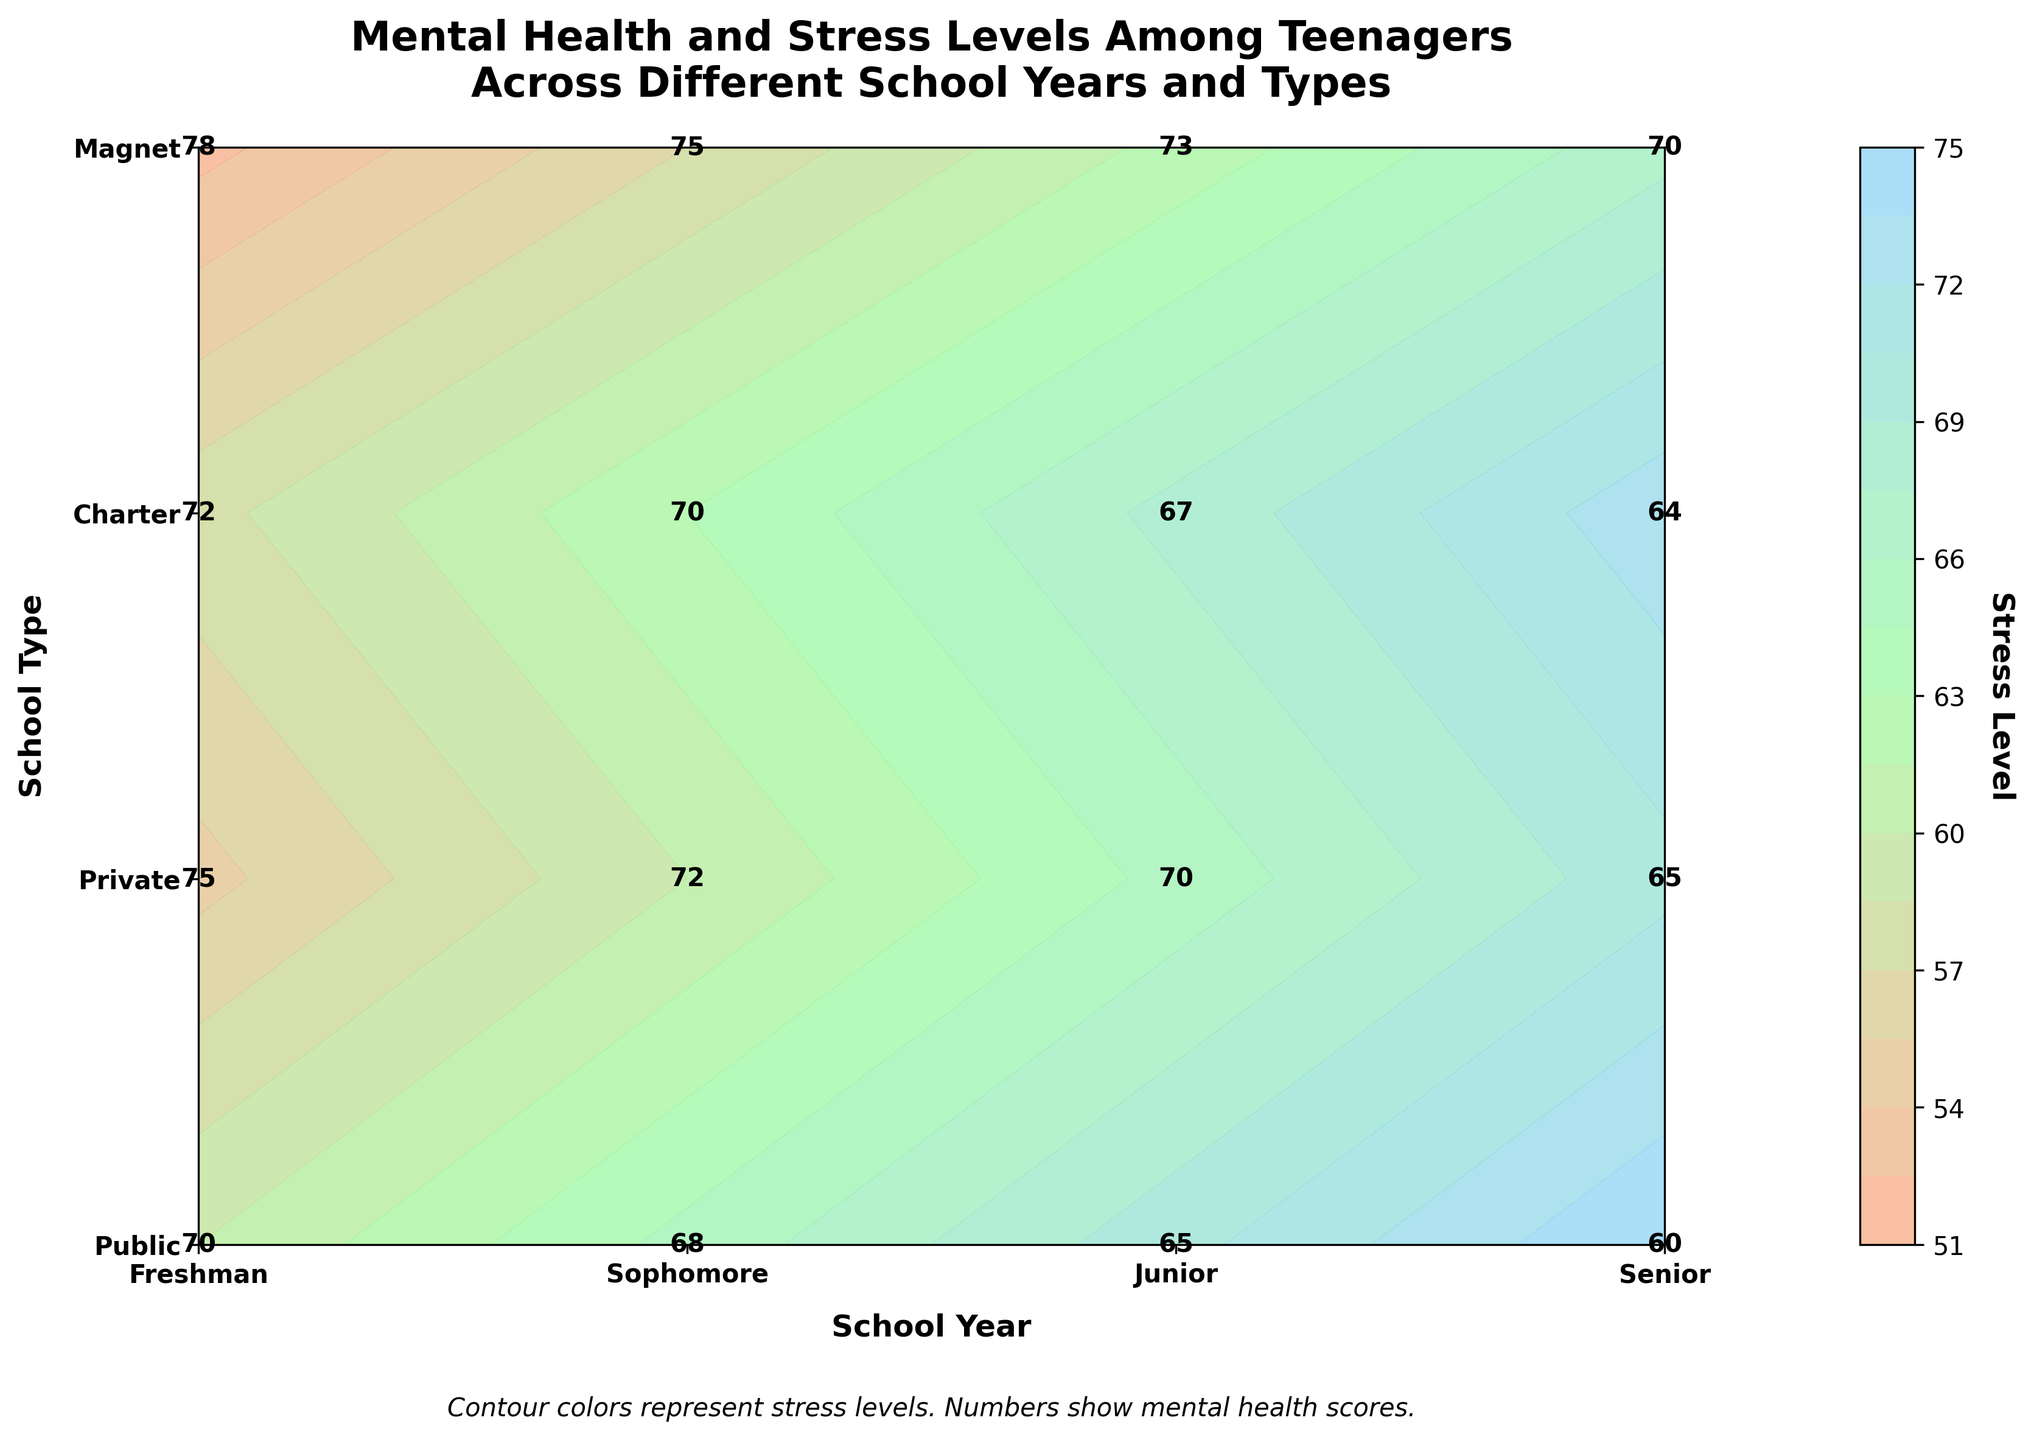What does the title of the plot indicate? The title tells us the plot shows both mental health and stress levels among teenagers across different school years and types of schools.
Answer: Mental Health and Stress Levels Among Teenagers Across Different School Years and Types of Schools What's the color representing higher stress levels? The contour colors ranging from orange to blue represent different stress levels, with orange representing higher stress levels.
Answer: Orange Where do Freshmen in Private schools stand in terms of mental health score? Look at the intersection of Freshman and Private on the plot and find the number displayed directly there.
Answer: 75 How do stress levels for Juniors compare between Public and Private schools? Locate the stress levels for Juniors in both Public (70) and Private (65) schools from the contours. Public schools have higher stress levels for Juniors.
Answer: Public schools have higher stress levels for Juniors Which school year and type has the highest mental health score? Identify the highest number displayed on the plot which is among Magnet schools for Freshmen.
Answer: Freshman, Magnet What's the difference in mental health scores between Seniors in Public and Charter schools? Locate and subtract the mental health scores for Seniors in Public (60) and Charter (64) schools.
Answer: 4 Compare the stress levels of Sophomores in Magnet schools and Charter schools. Which has less stress? Check the contours for Sophomores in Magnet (57) and Charter (63) schools. Magnet schools have less stress.
Answer: Magnet schools have less stress How do senior stress levels change from Freshman to Senior year in Public schools? Observe stress contours for Freshman (60), Sophomore (65), Junior (70), and Senior (75) year in Public schools. Stress levels steadily increase.
Answer: Increase What is the average mental health score for all Sophomore students across all school types? Add the mental health scores for Sophomores in Public (68), Private (72), Charter (70), and Magnet (75) schools and divide by 4.
Answer: 71.25 What's the overall trend in mental health scores as school year progresses in Magnet schools? Observe the values from Freshman to Senior year (78, 75, 73, 70). There is a general decline in mental health scores.
Answer: Decline 